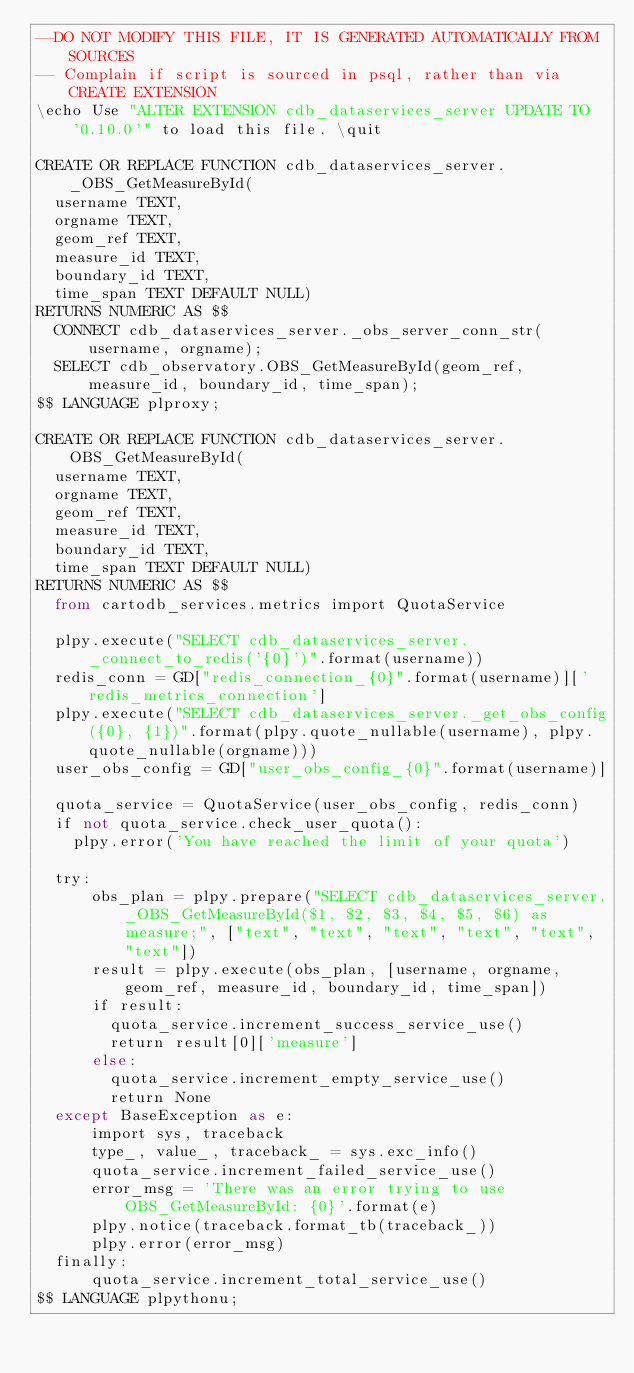Convert code to text. <code><loc_0><loc_0><loc_500><loc_500><_SQL_>--DO NOT MODIFY THIS FILE, IT IS GENERATED AUTOMATICALLY FROM SOURCES
-- Complain if script is sourced in psql, rather than via CREATE EXTENSION
\echo Use "ALTER EXTENSION cdb_dataservices_server UPDATE TO '0.10.0'" to load this file. \quit

CREATE OR REPLACE FUNCTION cdb_dataservices_server._OBS_GetMeasureById(
  username TEXT,
  orgname TEXT,
  geom_ref TEXT,
  measure_id TEXT,
  boundary_id TEXT,
  time_span TEXT DEFAULT NULL)
RETURNS NUMERIC AS $$
  CONNECT cdb_dataservices_server._obs_server_conn_str(username, orgname);
  SELECT cdb_observatory.OBS_GetMeasureById(geom_ref, measure_id, boundary_id, time_span);
$$ LANGUAGE plproxy;

CREATE OR REPLACE FUNCTION cdb_dataservices_server.OBS_GetMeasureById(
  username TEXT,
  orgname TEXT,
  geom_ref TEXT,
  measure_id TEXT,
  boundary_id TEXT,
  time_span TEXT DEFAULT NULL)
RETURNS NUMERIC AS $$
  from cartodb_services.metrics import QuotaService

  plpy.execute("SELECT cdb_dataservices_server._connect_to_redis('{0}')".format(username))
  redis_conn = GD["redis_connection_{0}".format(username)]['redis_metrics_connection']
  plpy.execute("SELECT cdb_dataservices_server._get_obs_config({0}, {1})".format(plpy.quote_nullable(username), plpy.quote_nullable(orgname)))
  user_obs_config = GD["user_obs_config_{0}".format(username)]

  quota_service = QuotaService(user_obs_config, redis_conn)
  if not quota_service.check_user_quota():
    plpy.error('You have reached the limit of your quota')

  try:
      obs_plan = plpy.prepare("SELECT cdb_dataservices_server._OBS_GetMeasureById($1, $2, $3, $4, $5, $6) as measure;", ["text", "text", "text", "text", "text", "text"])
      result = plpy.execute(obs_plan, [username, orgname, geom_ref, measure_id, boundary_id, time_span])
      if result:
        quota_service.increment_success_service_use()
        return result[0]['measure']
      else:
        quota_service.increment_empty_service_use()
        return None
  except BaseException as e:
      import sys, traceback
      type_, value_, traceback_ = sys.exc_info()
      quota_service.increment_failed_service_use()
      error_msg = 'There was an error trying to use OBS_GetMeasureById: {0}'.format(e)
      plpy.notice(traceback.format_tb(traceback_))
      plpy.error(error_msg)
  finally:
      quota_service.increment_total_service_use()
$$ LANGUAGE plpythonu;
</code> 